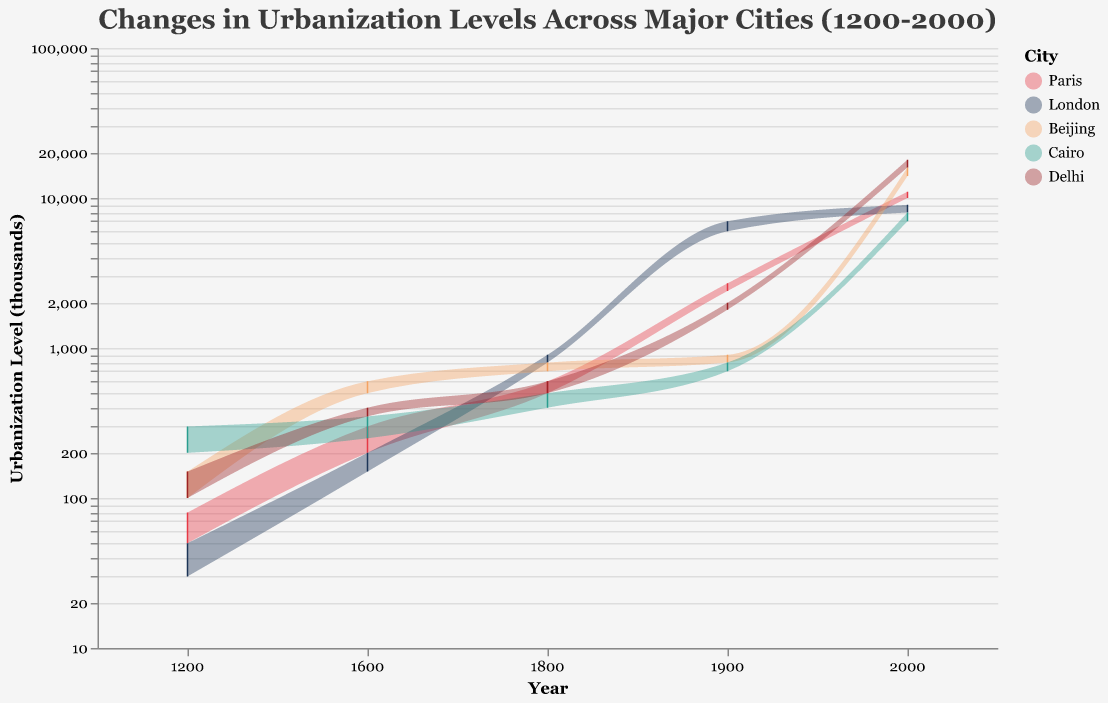What is the title of the chart? The title is typically displayed at the top of the chart. Here, it reads "Changes in Urbanization Levels Across Major Cities (1200-2000)"
Answer: Changes in Urbanization Levels Across Major Cities (1200-2000) How many cities are represented in the chart? The legend shows five different colors, each representing a city. These cities are Paris, London, Beijing, Cairo, and Delhi.
Answer: 5 What is the log scale used for on the y-axis? The y-axis label indicates "Urbanization Level (thousands)" and it uses a logarithmic scale to better display the wide range in urbanization levels from thousands to tens of thousands.
Answer: Urbanization Level (thousands) Which city had the highest range of urbanization in the year 2000? Beijing and Delhi have higher upper bounds, but Delhi's range is from 16,000 to 18,000 (a span of 2,000), while Beijing's is 14,000 to 16,000 (a span of 2,000). Both spans are 2,000, so it is a tie.
Answer: Delhi and Beijing What is the color representing the city of Cairo? The legend shows that Cairo is represented by the color "#2A9D8F" which is a shade of green.
Answer: Green Which city showed the greatest increase in urbanization from 1200 to 2000? Compare the urbanization range in 1200 and 2000 for all cities. Paris increased from 50-80 to 10,000-11,000, London from 30-50 to 8,000-9,000, Beijing from 100-150 to 14,000-16,000, Cairo from 200-300 to 7,000-8,000, and Delhi from 100-150 to 16,000-18,000. Delhi showed the greatest increase.
Answer: Delhi What was the minimum urbanization level for Beijing in 1800? Look at the range for Beijing in 1800 and find the lower bound. It ranges from 700 to 800, so the minimum is 700.
Answer: 700 Which city had a higher maximum urbanization level in 1900, London or Paris? Compare the upper bounds for both cities in 1900. London's max is 7,000 and Paris's is 2,700. London had a higher level.
Answer: London How did the urbanization level of Cairo change between 1200 and 1600? For Cairo, in 1200 the range is 200-300 and in 1600 it is 250-350. The increase is 50 within the minimum and 50 within the maximum levels.
Answer: Increased by 50, for both minimum and maximum If one were to average the maximum urbanization levels of all cities for the year 2000, what would the average be? Sum the maximum values for all cities in 2000: 11,000 (Paris), 9,000 (London), 16,000 (Beijing), 8,000 (Cairo), 18,000 (Delhi). Total is 62,000 and divide by 5 cities, the average is 12,400.
Answer: 12,400 